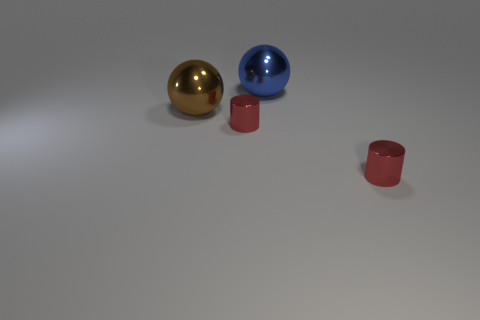What number of cubes are either red metallic things or blue shiny things?
Keep it short and to the point. 0. Is the number of blue metal spheres greater than the number of shiny cylinders?
Ensure brevity in your answer.  No. What number of balls are the same size as the blue metallic thing?
Your answer should be very brief. 1. How many things are red cylinders that are on the left side of the blue metallic sphere or big spheres?
Ensure brevity in your answer.  3. Is the number of tiny metal cylinders less than the number of things?
Offer a terse response. Yes. There is a large blue object that is made of the same material as the big brown ball; what shape is it?
Your response must be concise. Sphere. There is a large blue shiny sphere; are there any small things on the right side of it?
Offer a very short reply. Yes. Is the number of big blue metal spheres in front of the large blue metallic thing less than the number of brown metal things?
Offer a terse response. Yes. What is the material of the blue ball?
Give a very brief answer. Metal. The metal thing that is in front of the big brown shiny ball and to the left of the blue sphere is what color?
Your response must be concise. Red. 